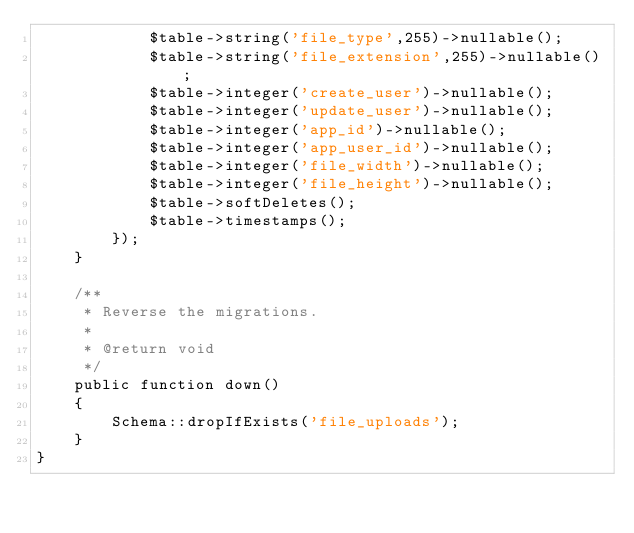Convert code to text. <code><loc_0><loc_0><loc_500><loc_500><_PHP_>            $table->string('file_type',255)->nullable();
            $table->string('file_extension',255)->nullable();
            $table->integer('create_user')->nullable();
            $table->integer('update_user')->nullable();
            $table->integer('app_id')->nullable();
            $table->integer('app_user_id')->nullable();
            $table->integer('file_width')->nullable();
            $table->integer('file_height')->nullable();
            $table->softDeletes();
            $table->timestamps();
        });
    }

    /**
     * Reverse the migrations.
     *
     * @return void
     */
    public function down()
    {
        Schema::dropIfExists('file_uploads');
    }
}
</code> 